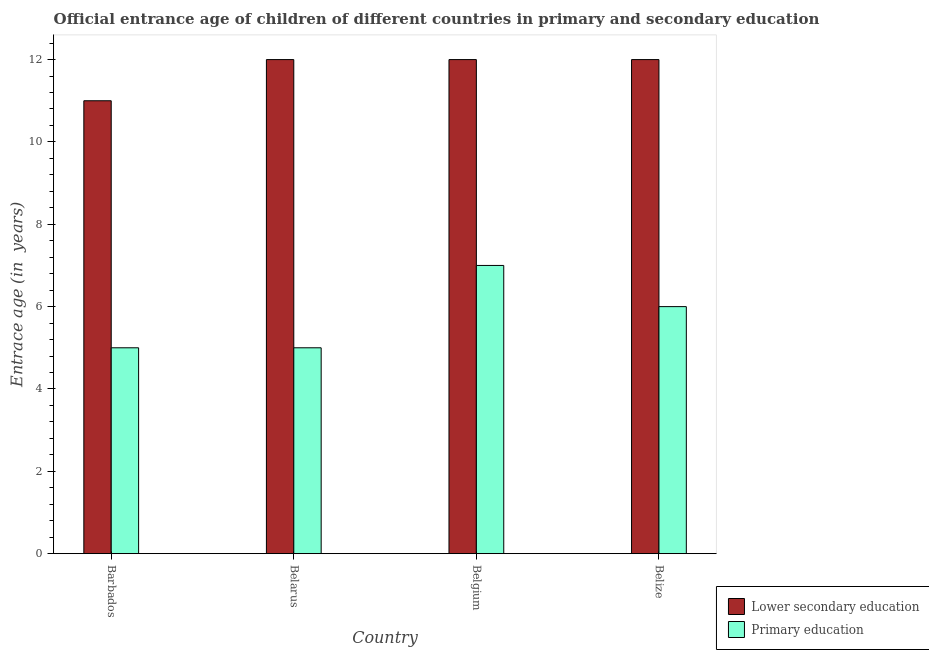Are the number of bars per tick equal to the number of legend labels?
Provide a succinct answer. Yes. How many bars are there on the 3rd tick from the right?
Provide a succinct answer. 2. What is the label of the 1st group of bars from the left?
Keep it short and to the point. Barbados. In how many cases, is the number of bars for a given country not equal to the number of legend labels?
Your answer should be very brief. 0. What is the entrance age of children in lower secondary education in Belize?
Offer a very short reply. 12. Across all countries, what is the maximum entrance age of children in lower secondary education?
Give a very brief answer. 12. Across all countries, what is the minimum entrance age of chiildren in primary education?
Provide a short and direct response. 5. In which country was the entrance age of children in lower secondary education maximum?
Your response must be concise. Belarus. In which country was the entrance age of children in lower secondary education minimum?
Your answer should be very brief. Barbados. What is the total entrance age of chiildren in primary education in the graph?
Offer a very short reply. 23. What is the difference between the entrance age of chiildren in primary education in Belarus and that in Belize?
Your response must be concise. -1. What is the difference between the entrance age of chiildren in primary education in Belize and the entrance age of children in lower secondary education in Barbados?
Make the answer very short. -5. What is the average entrance age of chiildren in primary education per country?
Offer a terse response. 5.75. What is the difference between the entrance age of chiildren in primary education and entrance age of children in lower secondary education in Belize?
Your answer should be very brief. -6. What is the ratio of the entrance age of children in lower secondary education in Barbados to that in Belize?
Give a very brief answer. 0.92. Is the difference between the entrance age of chiildren in primary education in Belgium and Belize greater than the difference between the entrance age of children in lower secondary education in Belgium and Belize?
Give a very brief answer. Yes. What is the difference between the highest and the second highest entrance age of chiildren in primary education?
Your response must be concise. 1. What is the difference between the highest and the lowest entrance age of children in lower secondary education?
Offer a terse response. 1. In how many countries, is the entrance age of chiildren in primary education greater than the average entrance age of chiildren in primary education taken over all countries?
Make the answer very short. 2. Is the sum of the entrance age of children in lower secondary education in Belgium and Belize greater than the maximum entrance age of chiildren in primary education across all countries?
Ensure brevity in your answer.  Yes. How many bars are there?
Keep it short and to the point. 8. Are all the bars in the graph horizontal?
Provide a short and direct response. No. How many countries are there in the graph?
Make the answer very short. 4. What is the difference between two consecutive major ticks on the Y-axis?
Provide a succinct answer. 2. Where does the legend appear in the graph?
Keep it short and to the point. Bottom right. What is the title of the graph?
Offer a very short reply. Official entrance age of children of different countries in primary and secondary education. What is the label or title of the X-axis?
Make the answer very short. Country. What is the label or title of the Y-axis?
Your answer should be compact. Entrace age (in  years). What is the Entrace age (in  years) of Primary education in Barbados?
Provide a short and direct response. 5. What is the Entrace age (in  years) in Primary education in Belarus?
Offer a terse response. 5. What is the Entrace age (in  years) in Lower secondary education in Belgium?
Provide a succinct answer. 12. What is the Entrace age (in  years) of Primary education in Belgium?
Provide a succinct answer. 7. What is the Entrace age (in  years) of Primary education in Belize?
Your response must be concise. 6. Across all countries, what is the minimum Entrace age (in  years) in Primary education?
Give a very brief answer. 5. What is the total Entrace age (in  years) of Lower secondary education in the graph?
Your response must be concise. 47. What is the total Entrace age (in  years) of Primary education in the graph?
Keep it short and to the point. 23. What is the difference between the Entrace age (in  years) of Lower secondary education in Barbados and that in Belarus?
Provide a succinct answer. -1. What is the difference between the Entrace age (in  years) in Lower secondary education in Barbados and that in Belgium?
Offer a very short reply. -1. What is the difference between the Entrace age (in  years) of Primary education in Barbados and that in Belgium?
Offer a very short reply. -2. What is the difference between the Entrace age (in  years) in Lower secondary education in Barbados and that in Belize?
Ensure brevity in your answer.  -1. What is the difference between the Entrace age (in  years) in Primary education in Barbados and that in Belize?
Ensure brevity in your answer.  -1. What is the difference between the Entrace age (in  years) in Lower secondary education in Belarus and that in Belize?
Keep it short and to the point. 0. What is the difference between the Entrace age (in  years) of Primary education in Belarus and that in Belize?
Make the answer very short. -1. What is the difference between the Entrace age (in  years) of Primary education in Belgium and that in Belize?
Your response must be concise. 1. What is the difference between the Entrace age (in  years) in Lower secondary education in Barbados and the Entrace age (in  years) in Primary education in Belarus?
Provide a short and direct response. 6. What is the difference between the Entrace age (in  years) in Lower secondary education in Barbados and the Entrace age (in  years) in Primary education in Belize?
Make the answer very short. 5. What is the difference between the Entrace age (in  years) of Lower secondary education in Belarus and the Entrace age (in  years) of Primary education in Belgium?
Your answer should be compact. 5. What is the difference between the Entrace age (in  years) of Lower secondary education in Belarus and the Entrace age (in  years) of Primary education in Belize?
Provide a short and direct response. 6. What is the difference between the Entrace age (in  years) in Lower secondary education in Belgium and the Entrace age (in  years) in Primary education in Belize?
Provide a short and direct response. 6. What is the average Entrace age (in  years) of Lower secondary education per country?
Give a very brief answer. 11.75. What is the average Entrace age (in  years) of Primary education per country?
Give a very brief answer. 5.75. What is the difference between the Entrace age (in  years) of Lower secondary education and Entrace age (in  years) of Primary education in Belarus?
Provide a succinct answer. 7. What is the difference between the Entrace age (in  years) in Lower secondary education and Entrace age (in  years) in Primary education in Belize?
Ensure brevity in your answer.  6. What is the ratio of the Entrace age (in  years) of Lower secondary education in Barbados to that in Belarus?
Offer a terse response. 0.92. What is the ratio of the Entrace age (in  years) of Primary education in Barbados to that in Belgium?
Make the answer very short. 0.71. What is the ratio of the Entrace age (in  years) of Lower secondary education in Barbados to that in Belize?
Offer a very short reply. 0.92. What is the ratio of the Entrace age (in  years) of Primary education in Barbados to that in Belize?
Your response must be concise. 0.83. What is the ratio of the Entrace age (in  years) of Lower secondary education in Belarus to that in Belgium?
Offer a terse response. 1. What is the ratio of the Entrace age (in  years) in Primary education in Belarus to that in Belgium?
Ensure brevity in your answer.  0.71. What is the ratio of the Entrace age (in  years) in Primary education in Belarus to that in Belize?
Provide a short and direct response. 0.83. What is the ratio of the Entrace age (in  years) in Lower secondary education in Belgium to that in Belize?
Your answer should be compact. 1. What is the difference between the highest and the lowest Entrace age (in  years) in Lower secondary education?
Ensure brevity in your answer.  1. What is the difference between the highest and the lowest Entrace age (in  years) in Primary education?
Make the answer very short. 2. 